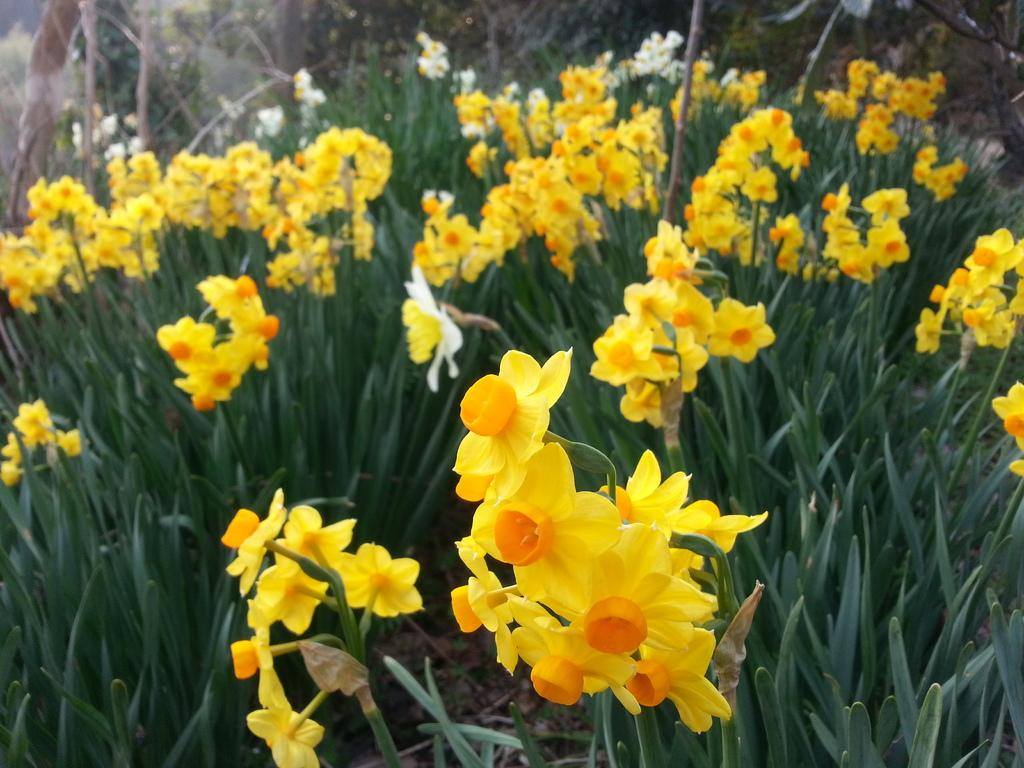Where was the image taken from? The image is taken from outside the city. What can be seen in the image besides the city? There are plants with flowers in the image. What color are the flowers? The flowers are yellow in color. What type of story is being told by the clock in the image? There is no clock present in the image, so no story can be told by a clock. What type of locket can be seen hanging from the flowers in the image? There is no locket present in the image; it only features plants with yellow flowers. 